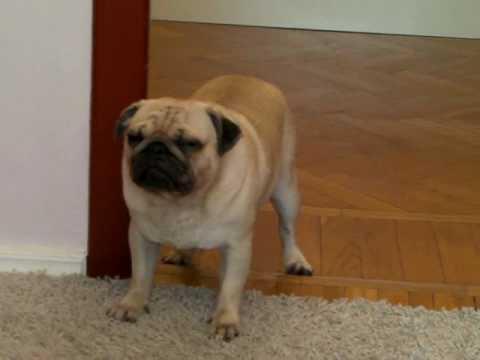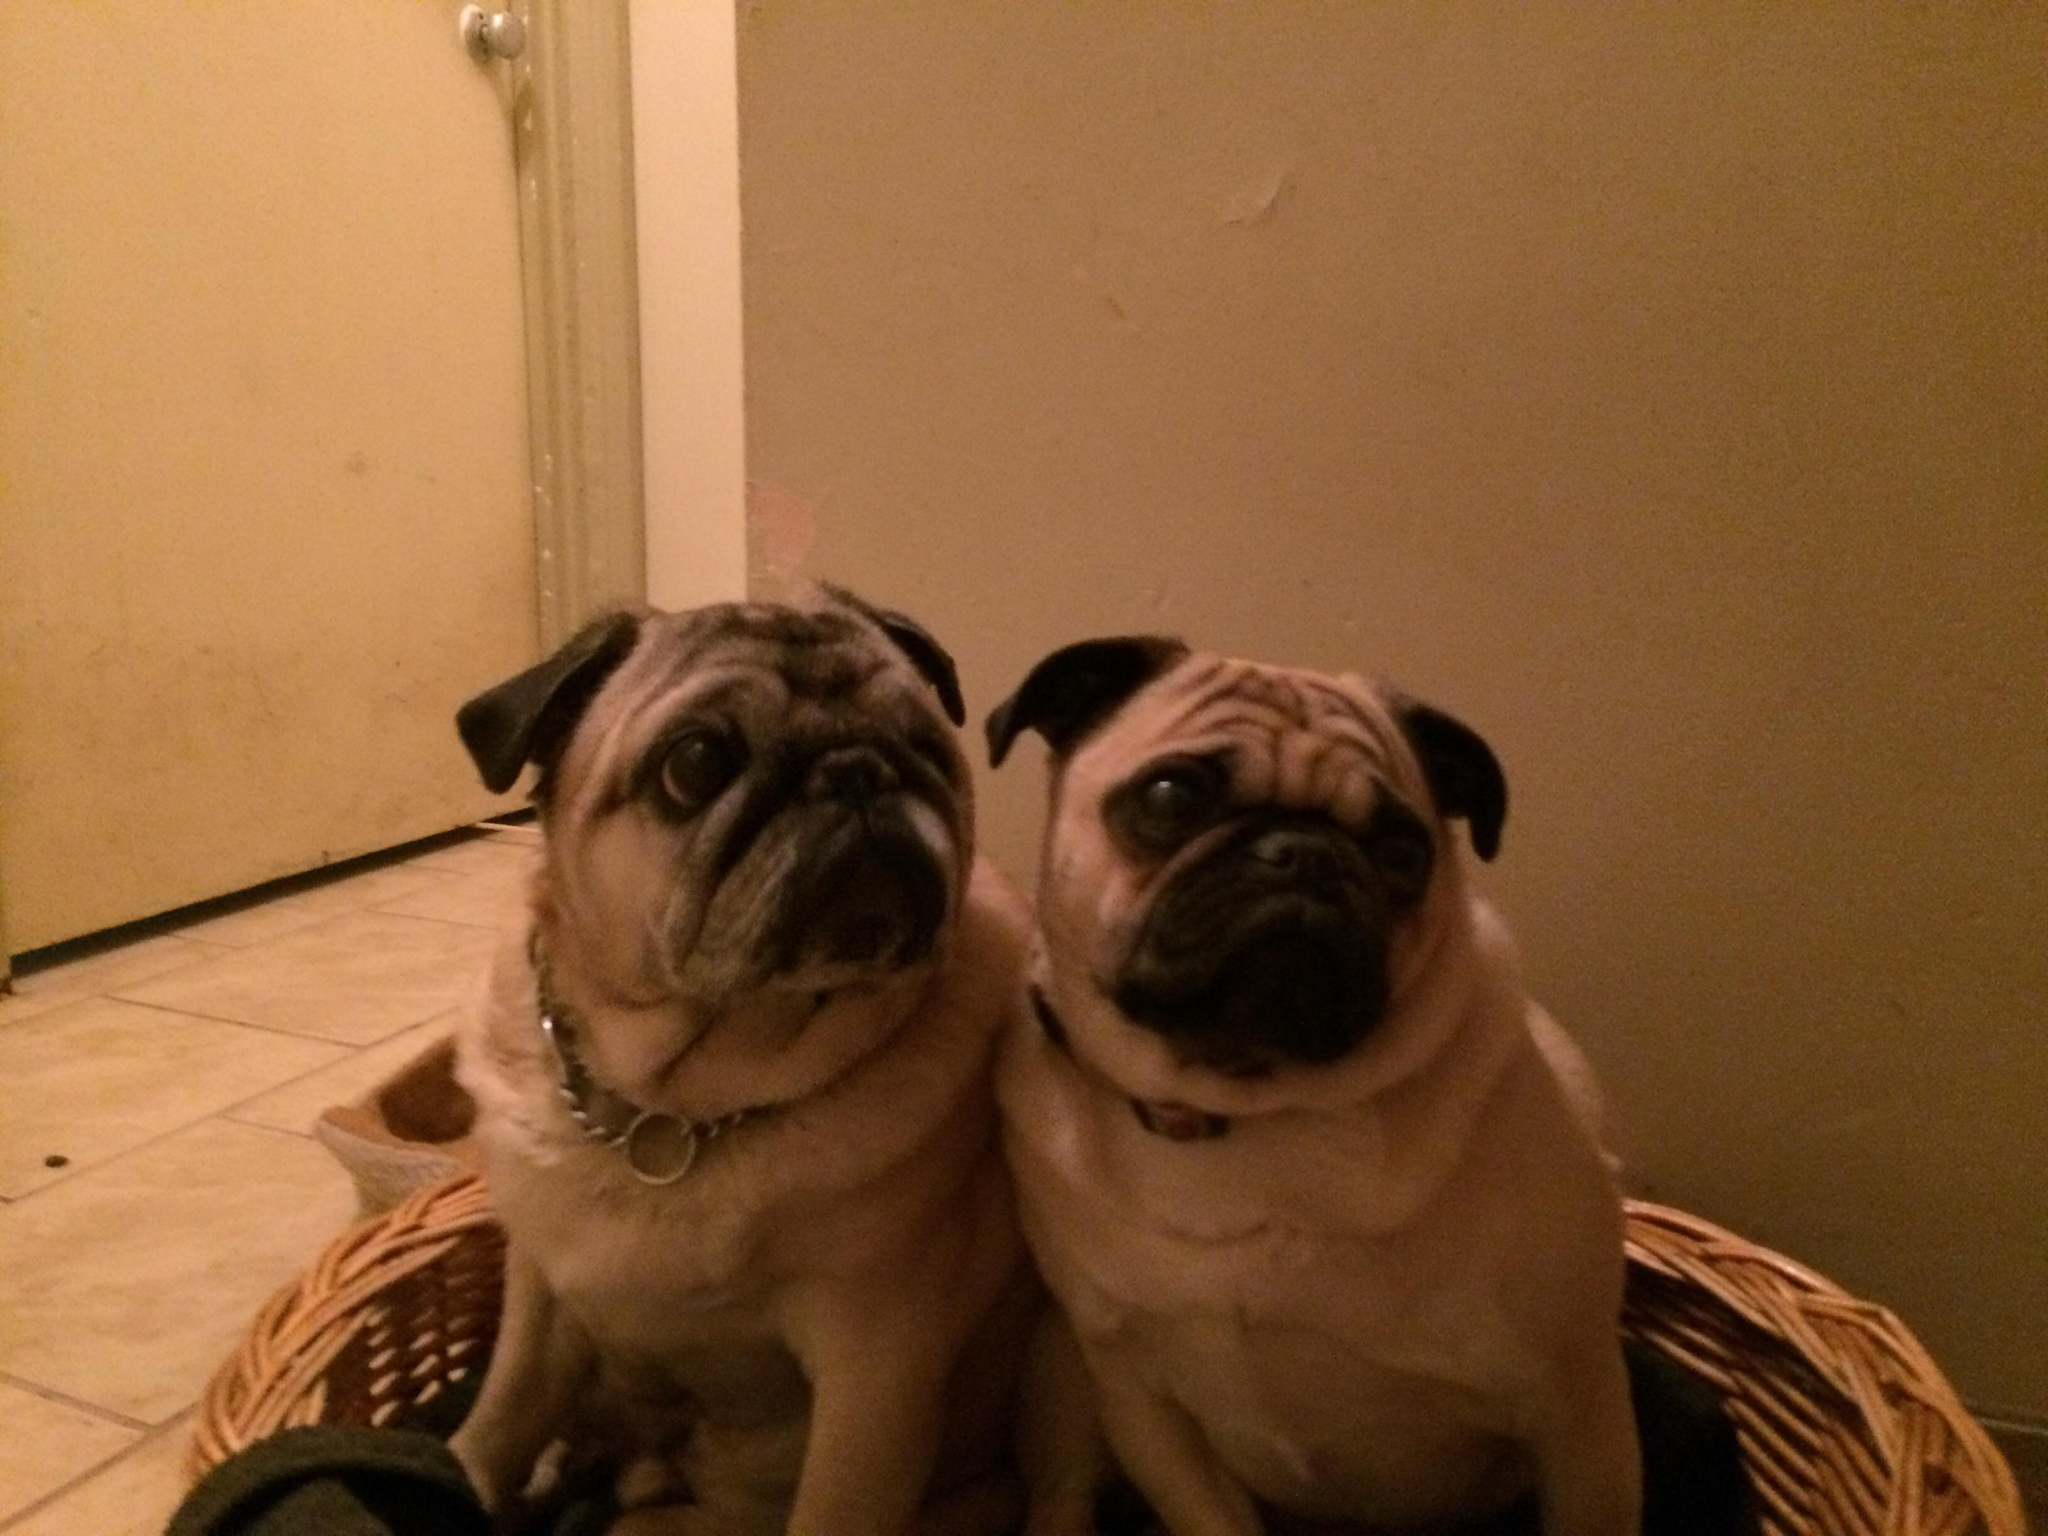The first image is the image on the left, the second image is the image on the right. Analyze the images presented: Is the assertion "An image shows two pug dogs side-by-side in a roundish container." valid? Answer yes or no. Yes. The first image is the image on the left, the second image is the image on the right. Assess this claim about the two images: "There is no more than one dog in the left image.". Correct or not? Answer yes or no. Yes. 